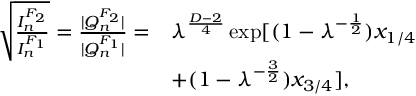<formula> <loc_0><loc_0><loc_500><loc_500>\begin{array} { r l } { \sqrt { \frac { I _ { n } ^ { F _ { 2 } } } { I _ { n } ^ { F _ { 1 } } } } = \frac { | Q _ { n } ^ { F _ { 2 } } | } { | Q _ { n } ^ { F _ { 1 } } | } = } & { \lambda ^ { \frac { D - 2 } { 4 } } \exp [ ( 1 - \lambda ^ { - \frac { 1 } { 2 } } ) x _ { 1 / 4 } } \\ & { + ( 1 - \lambda ^ { - \frac { 3 } { 2 } } ) x _ { 3 / 4 } ] , } \end{array}</formula> 